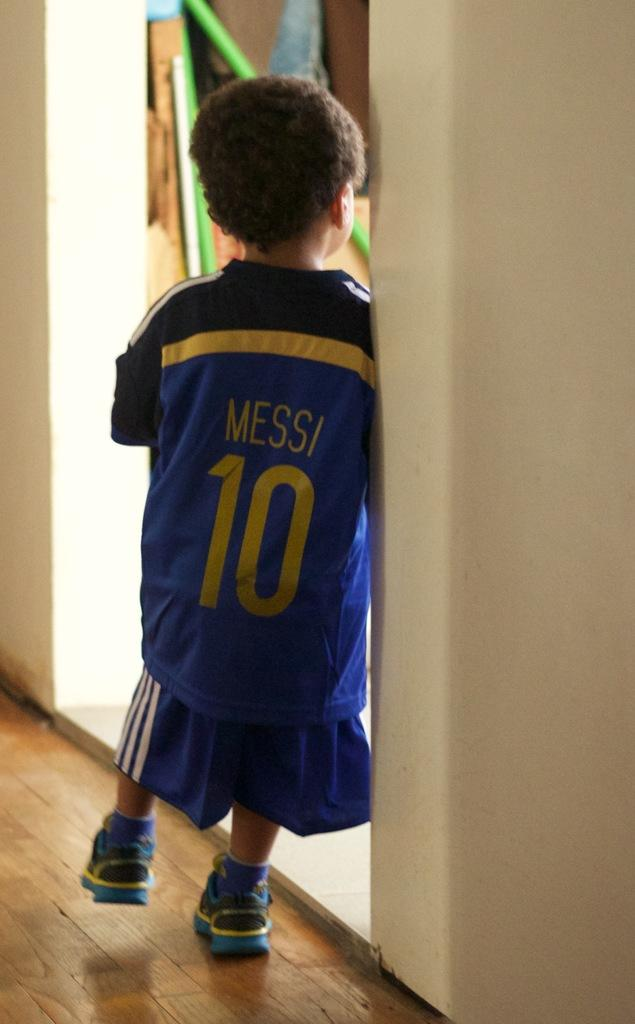<image>
Create a compact narrative representing the image presented. a back side of a boy wearing a Messi 10 jersey 